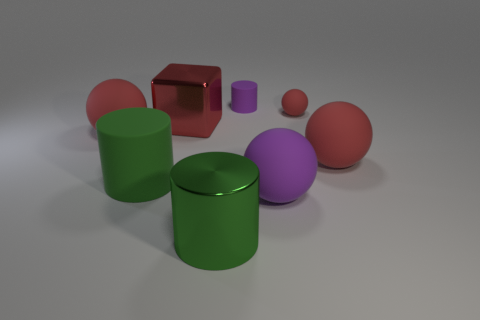Subtract all purple blocks. How many red spheres are left? 3 Subtract all yellow balls. Subtract all brown cubes. How many balls are left? 4 Add 1 green rubber cylinders. How many objects exist? 9 Subtract all blocks. How many objects are left? 7 Subtract all rubber things. Subtract all large green objects. How many objects are left? 0 Add 4 large green matte cylinders. How many large green matte cylinders are left? 5 Add 6 small spheres. How many small spheres exist? 7 Subtract 1 purple cylinders. How many objects are left? 7 